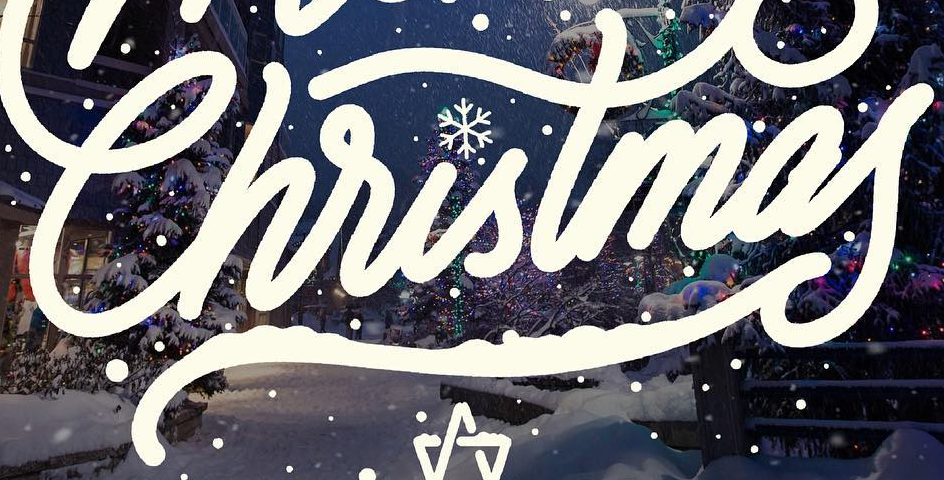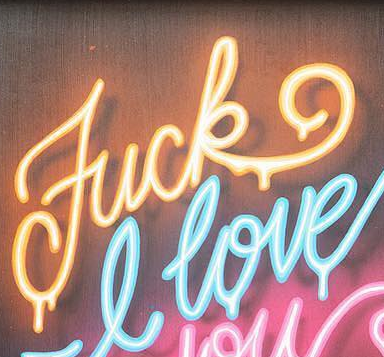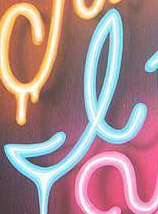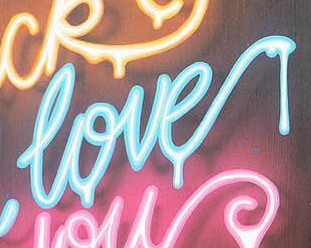What words can you see in these images in sequence, separated by a semicolon? Christmas; Fuck; I; love 